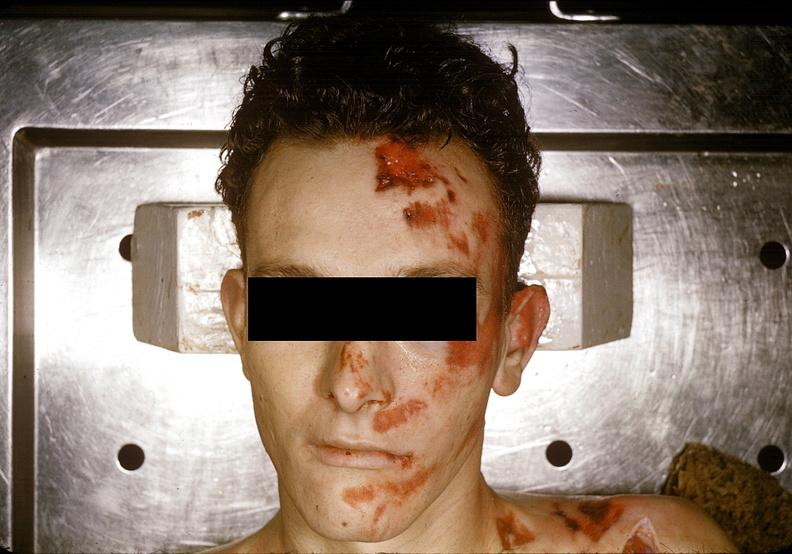does this image show head and face, severe trauma, contusion, lacerations, abrasions?
Answer the question using a single word or phrase. Yes 